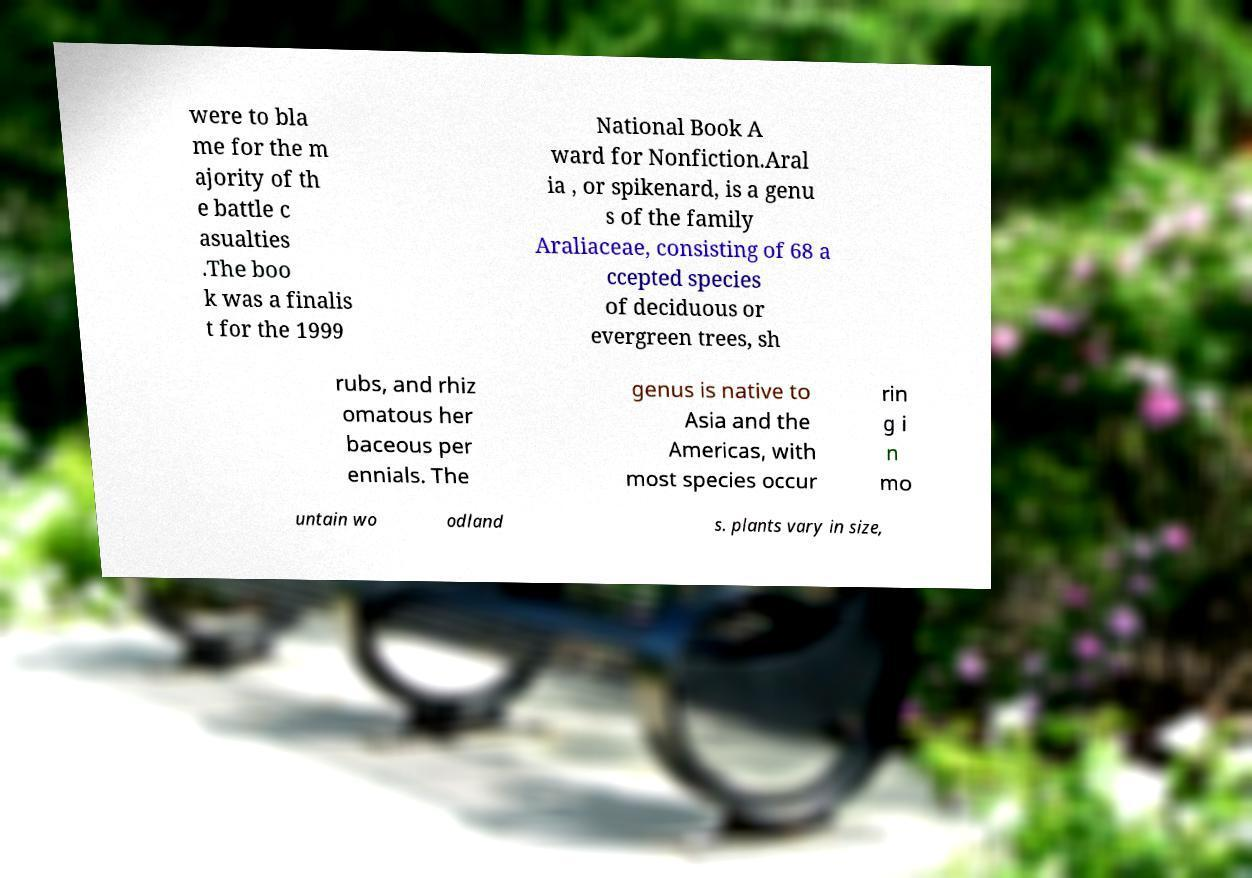There's text embedded in this image that I need extracted. Can you transcribe it verbatim? were to bla me for the m ajority of th e battle c asualties .The boo k was a finalis t for the 1999 National Book A ward for Nonfiction.Aral ia , or spikenard, is a genu s of the family Araliaceae, consisting of 68 a ccepted species of deciduous or evergreen trees, sh rubs, and rhiz omatous her baceous per ennials. The genus is native to Asia and the Americas, with most species occur rin g i n mo untain wo odland s. plants vary in size, 